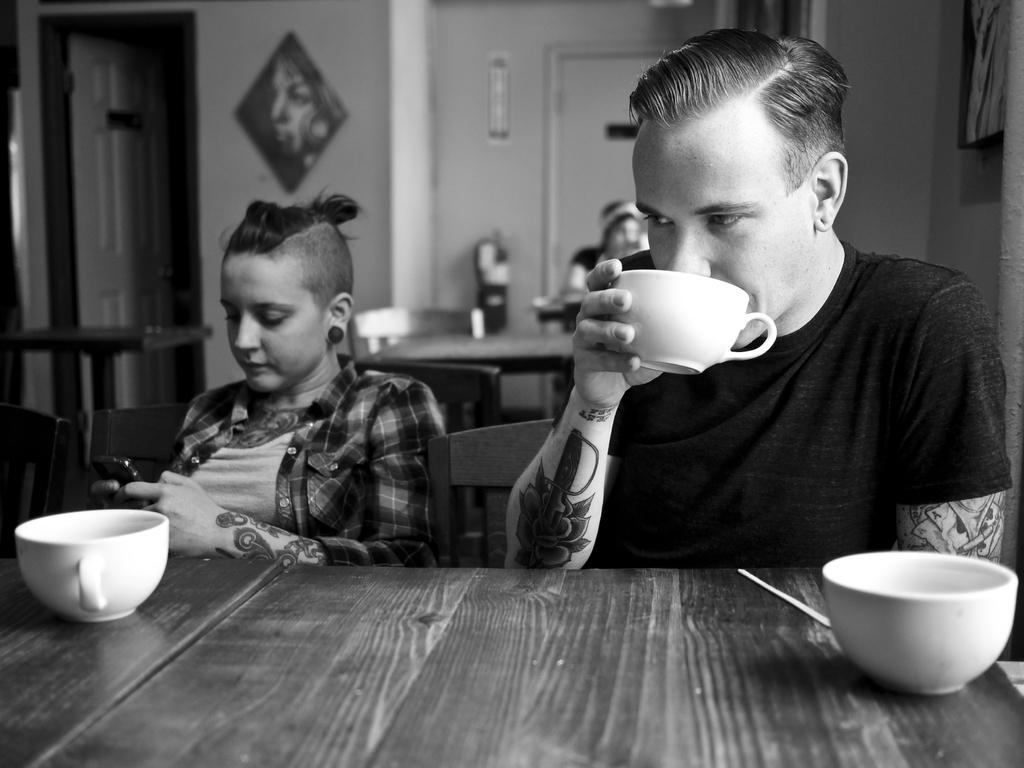Please provide a concise description of this image. We can see frame, light over a wall. These are doors. We can see persons sitting on chairs near to the table. This man is drinking a cup of tea or coffee. On the table we can see cups, stick. This woman is holding a mobile in her hands. 